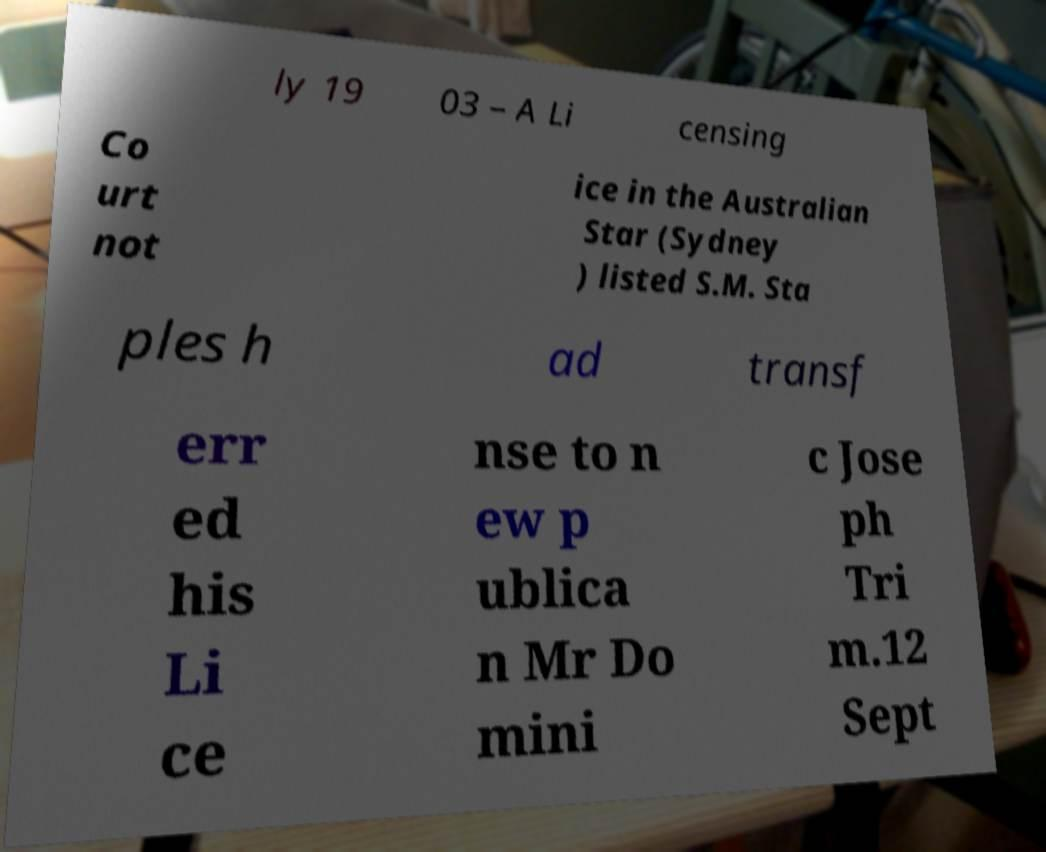Please read and relay the text visible in this image. What does it say? ly 19 03 – A Li censing Co urt not ice in the Australian Star (Sydney ) listed S.M. Sta ples h ad transf err ed his Li ce nse to n ew p ublica n Mr Do mini c Jose ph Tri m.12 Sept 